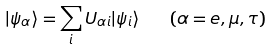<formula> <loc_0><loc_0><loc_500><loc_500>| \psi _ { \alpha } \rangle = \sum _ { i } U _ { \alpha i } | \psi _ { i } \rangle \quad ( \alpha = e , \mu , \tau )</formula> 